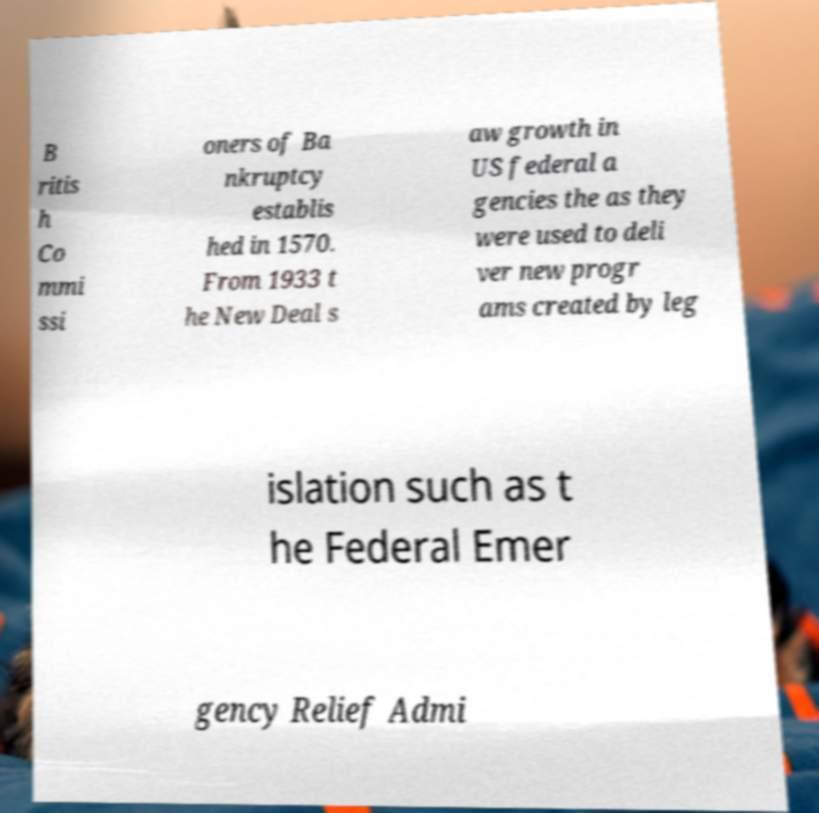What messages or text are displayed in this image? I need them in a readable, typed format. B ritis h Co mmi ssi oners of Ba nkruptcy establis hed in 1570. From 1933 t he New Deal s aw growth in US federal a gencies the as they were used to deli ver new progr ams created by leg islation such as t he Federal Emer gency Relief Admi 